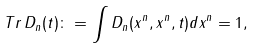<formula> <loc_0><loc_0><loc_500><loc_500>T r \, D _ { n } ( t ) \colon = \int D _ { n } ( x ^ { n } , x ^ { n } , t ) d x ^ { n } = 1 ,</formula> 